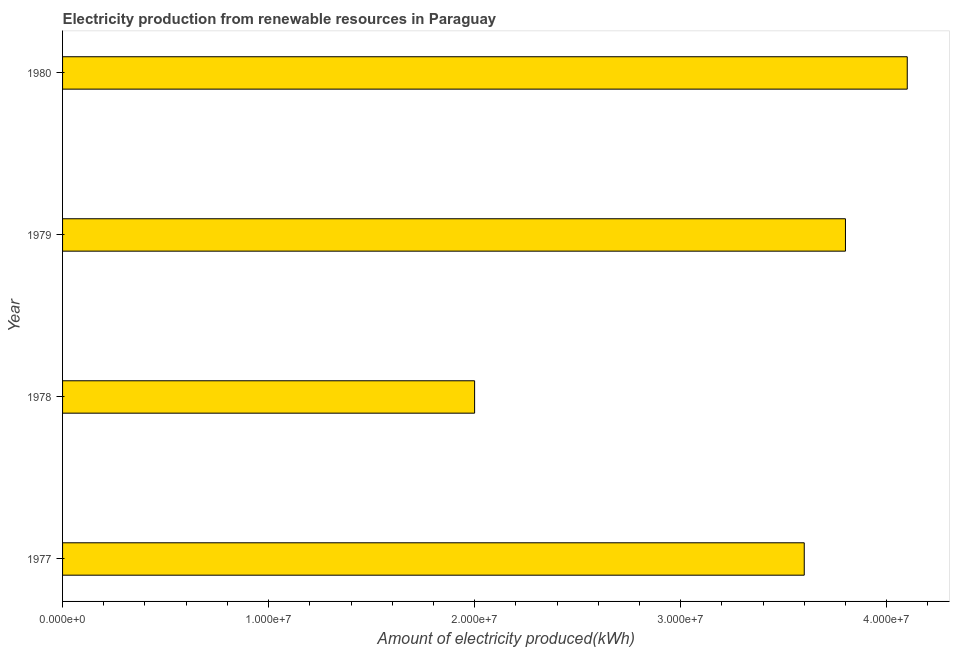Does the graph contain grids?
Give a very brief answer. No. What is the title of the graph?
Provide a succinct answer. Electricity production from renewable resources in Paraguay. What is the label or title of the X-axis?
Your answer should be very brief. Amount of electricity produced(kWh). What is the amount of electricity produced in 1980?
Provide a short and direct response. 4.10e+07. Across all years, what is the maximum amount of electricity produced?
Your answer should be very brief. 4.10e+07. Across all years, what is the minimum amount of electricity produced?
Make the answer very short. 2.00e+07. In which year was the amount of electricity produced minimum?
Offer a terse response. 1978. What is the sum of the amount of electricity produced?
Keep it short and to the point. 1.35e+08. What is the difference between the amount of electricity produced in 1978 and 1980?
Your response must be concise. -2.10e+07. What is the average amount of electricity produced per year?
Offer a very short reply. 3.38e+07. What is the median amount of electricity produced?
Ensure brevity in your answer.  3.70e+07. Do a majority of the years between 1979 and 1978 (inclusive) have amount of electricity produced greater than 36000000 kWh?
Your response must be concise. No. What is the ratio of the amount of electricity produced in 1979 to that in 1980?
Make the answer very short. 0.93. Is the sum of the amount of electricity produced in 1979 and 1980 greater than the maximum amount of electricity produced across all years?
Give a very brief answer. Yes. What is the difference between the highest and the lowest amount of electricity produced?
Your response must be concise. 2.10e+07. In how many years, is the amount of electricity produced greater than the average amount of electricity produced taken over all years?
Your response must be concise. 3. What is the difference between two consecutive major ticks on the X-axis?
Provide a short and direct response. 1.00e+07. Are the values on the major ticks of X-axis written in scientific E-notation?
Give a very brief answer. Yes. What is the Amount of electricity produced(kWh) of 1977?
Your response must be concise. 3.60e+07. What is the Amount of electricity produced(kWh) of 1979?
Your response must be concise. 3.80e+07. What is the Amount of electricity produced(kWh) in 1980?
Your answer should be compact. 4.10e+07. What is the difference between the Amount of electricity produced(kWh) in 1977 and 1978?
Your answer should be compact. 1.60e+07. What is the difference between the Amount of electricity produced(kWh) in 1977 and 1980?
Keep it short and to the point. -5.00e+06. What is the difference between the Amount of electricity produced(kWh) in 1978 and 1979?
Offer a very short reply. -1.80e+07. What is the difference between the Amount of electricity produced(kWh) in 1978 and 1980?
Offer a terse response. -2.10e+07. What is the difference between the Amount of electricity produced(kWh) in 1979 and 1980?
Your answer should be compact. -3.00e+06. What is the ratio of the Amount of electricity produced(kWh) in 1977 to that in 1979?
Your answer should be very brief. 0.95. What is the ratio of the Amount of electricity produced(kWh) in 1977 to that in 1980?
Provide a short and direct response. 0.88. What is the ratio of the Amount of electricity produced(kWh) in 1978 to that in 1979?
Offer a terse response. 0.53. What is the ratio of the Amount of electricity produced(kWh) in 1978 to that in 1980?
Ensure brevity in your answer.  0.49. What is the ratio of the Amount of electricity produced(kWh) in 1979 to that in 1980?
Give a very brief answer. 0.93. 